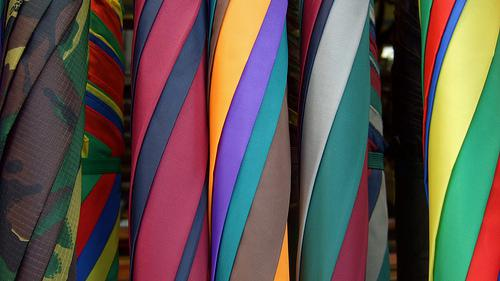Question: what color are the umbrellas?
Choices:
A. Pink.
B. Blue.
C. Multi colored.
D. Green.
Answer with the letter. Answer: C Question: what is shown?
Choices:
A. Umbrellas.
B. Mountains.
C. Cows.
D. Horses.
Answer with the letter. Answer: A Question: what pattern is the far left umbrella?
Choices:
A. Squares.
B. Camoflage.
C. Twirl pattern.
D. Cartoon figures.
Answer with the letter. Answer: B Question: how many umbrellas are shownn?
Choices:
A. One.
B. Two.
C. Six.
D. Three.
Answer with the letter. Answer: C 